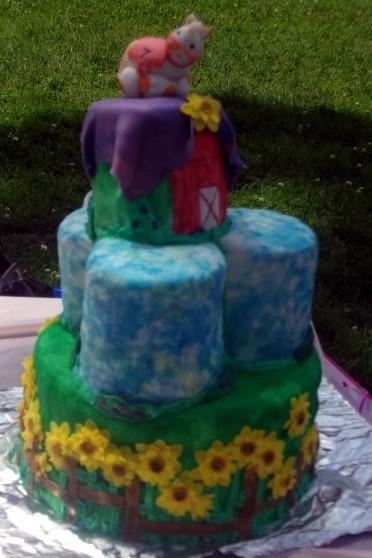How many cakes are there?
Give a very brief answer. 3. 